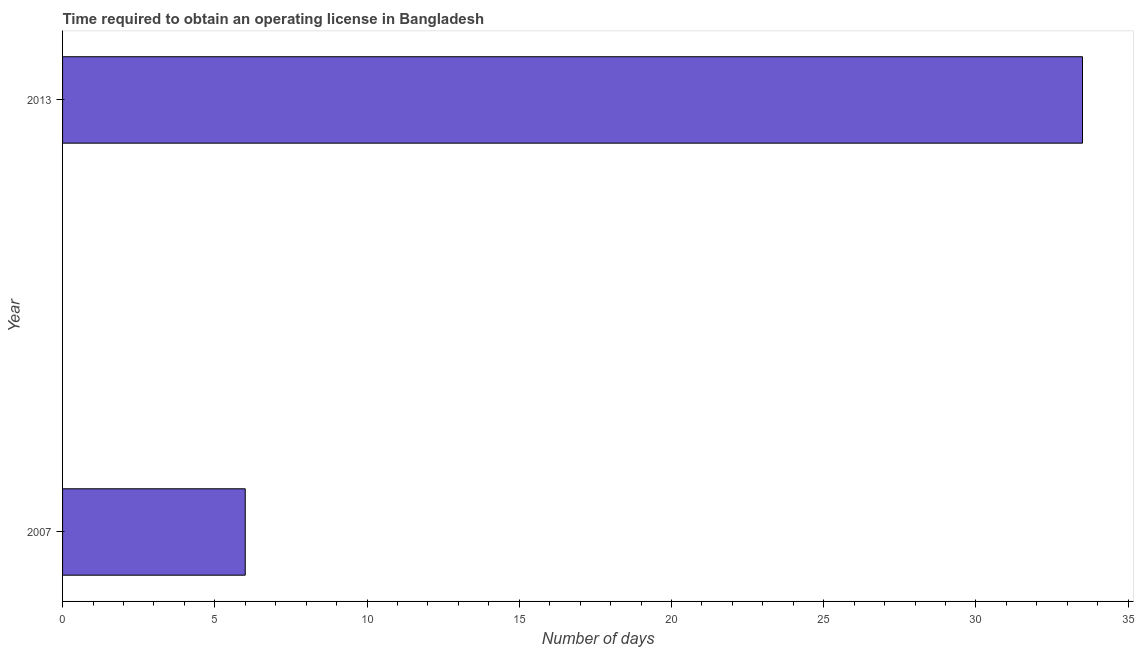Does the graph contain grids?
Ensure brevity in your answer.  No. What is the title of the graph?
Provide a short and direct response. Time required to obtain an operating license in Bangladesh. What is the label or title of the X-axis?
Offer a very short reply. Number of days. What is the label or title of the Y-axis?
Keep it short and to the point. Year. Across all years, what is the maximum number of days to obtain operating license?
Offer a terse response. 33.5. Across all years, what is the minimum number of days to obtain operating license?
Make the answer very short. 6. In which year was the number of days to obtain operating license maximum?
Give a very brief answer. 2013. In which year was the number of days to obtain operating license minimum?
Give a very brief answer. 2007. What is the sum of the number of days to obtain operating license?
Ensure brevity in your answer.  39.5. What is the difference between the number of days to obtain operating license in 2007 and 2013?
Your answer should be compact. -27.5. What is the average number of days to obtain operating license per year?
Provide a short and direct response. 19.75. What is the median number of days to obtain operating license?
Offer a terse response. 19.75. In how many years, is the number of days to obtain operating license greater than 9 days?
Offer a terse response. 1. Do a majority of the years between 2007 and 2013 (inclusive) have number of days to obtain operating license greater than 2 days?
Make the answer very short. Yes. What is the ratio of the number of days to obtain operating license in 2007 to that in 2013?
Your answer should be very brief. 0.18. Is the number of days to obtain operating license in 2007 less than that in 2013?
Provide a succinct answer. Yes. In how many years, is the number of days to obtain operating license greater than the average number of days to obtain operating license taken over all years?
Provide a short and direct response. 1. How many bars are there?
Provide a short and direct response. 2. How many years are there in the graph?
Your response must be concise. 2. Are the values on the major ticks of X-axis written in scientific E-notation?
Provide a short and direct response. No. What is the Number of days of 2007?
Offer a terse response. 6. What is the Number of days in 2013?
Provide a succinct answer. 33.5. What is the difference between the Number of days in 2007 and 2013?
Offer a very short reply. -27.5. What is the ratio of the Number of days in 2007 to that in 2013?
Ensure brevity in your answer.  0.18. 